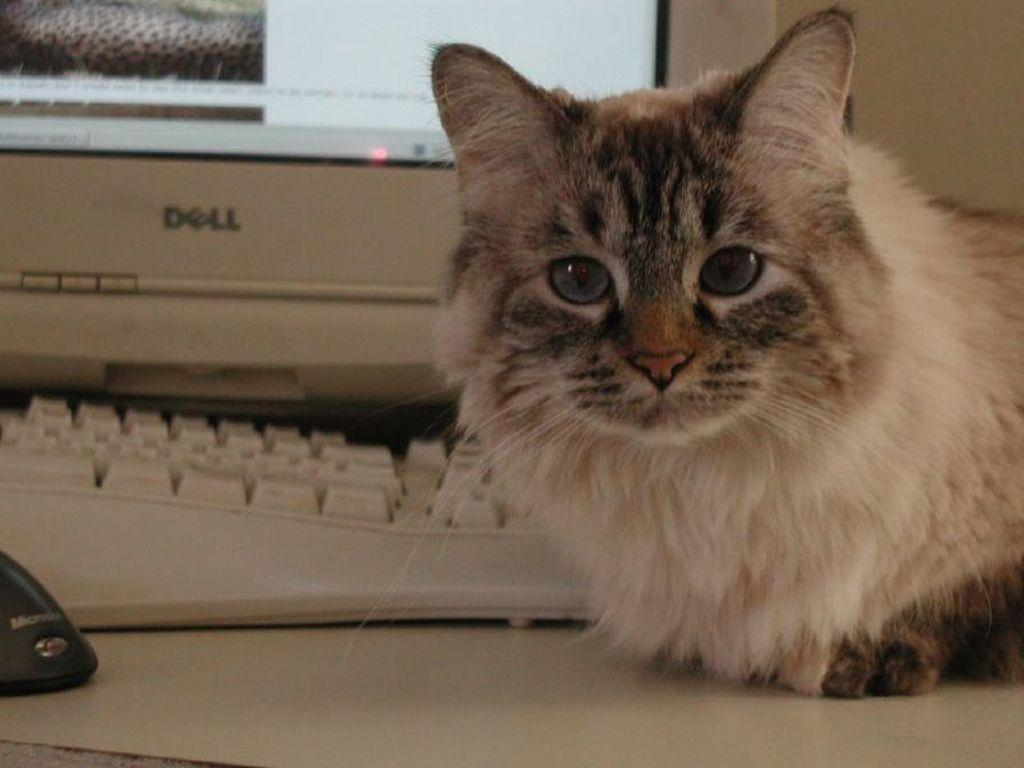What type of furniture is present in the image? There is a table in the image. What is on top of the table? There is a screen, a keyboard, a mouse, and a cat on the table. What might be used for input and navigation on the screen? The mouse on the table might be used for input and navigation on the screen. What type of animal is present on the table? There is a cat on the table. How many dolls are present on the table in the image? There are no dolls present on the table in the image. What type of magic is being performed by the cat on the table? There is no magic being performed by the cat on the table; it is simply a cat sitting on the table. 